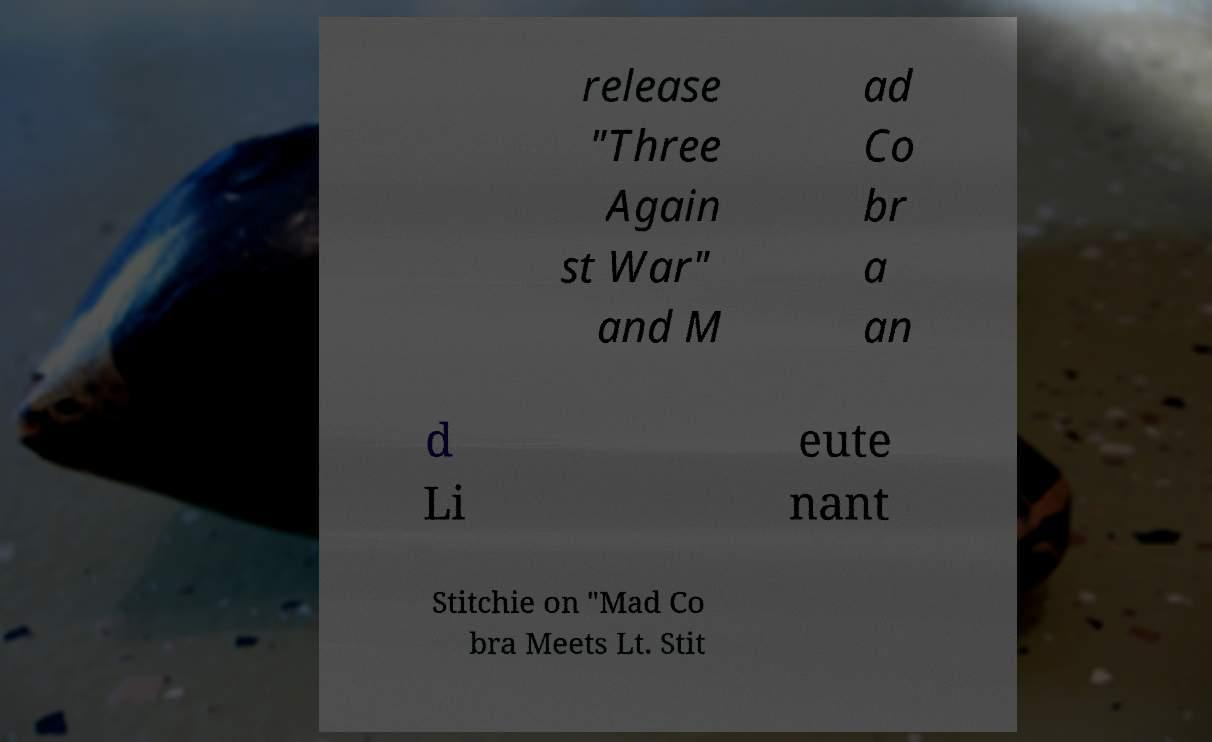Please identify and transcribe the text found in this image. release "Three Again st War" and M ad Co br a an d Li eute nant Stitchie on "Mad Co bra Meets Lt. Stit 